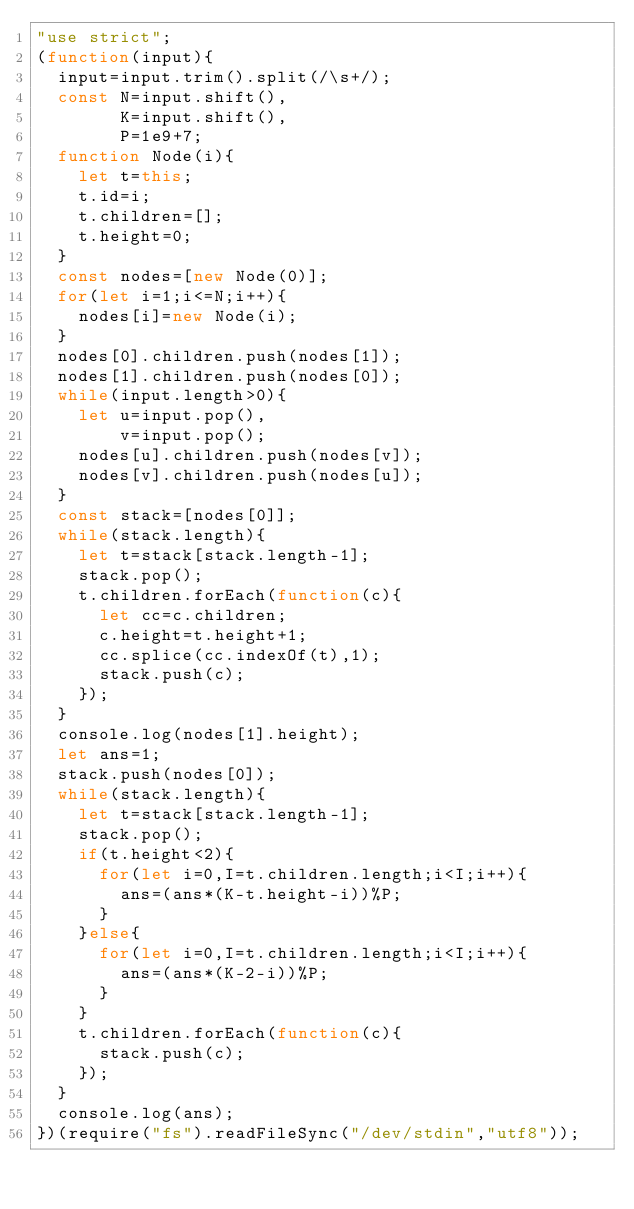<code> <loc_0><loc_0><loc_500><loc_500><_JavaScript_>"use strict";
(function(input){
  input=input.trim().split(/\s+/);
  const N=input.shift(),
        K=input.shift(),
        P=1e9+7;
  function Node(i){
    let t=this;
    t.id=i;
    t.children=[];
    t.height=0;
  }
  const nodes=[new Node(0)];
  for(let i=1;i<=N;i++){
    nodes[i]=new Node(i);
  }
  nodes[0].children.push(nodes[1]);
  nodes[1].children.push(nodes[0]);
  while(input.length>0){
    let u=input.pop(),
        v=input.pop();
    nodes[u].children.push(nodes[v]);
    nodes[v].children.push(nodes[u]);
  }
  const stack=[nodes[0]];
  while(stack.length){
    let t=stack[stack.length-1];
    stack.pop();
    t.children.forEach(function(c){
      let cc=c.children;
      c.height=t.height+1;
      cc.splice(cc.indexOf(t),1);
      stack.push(c);
    });
  }
  console.log(nodes[1].height);
  let ans=1;
  stack.push(nodes[0]);
  while(stack.length){
    let t=stack[stack.length-1];
    stack.pop();
    if(t.height<2){
      for(let i=0,I=t.children.length;i<I;i++){
        ans=(ans*(K-t.height-i))%P;
      }
    }else{
      for(let i=0,I=t.children.length;i<I;i++){
        ans=(ans*(K-2-i))%P;
      }
    }
    t.children.forEach(function(c){
      stack.push(c);
    });
  }
  console.log(ans);
})(require("fs").readFileSync("/dev/stdin","utf8"));
</code> 